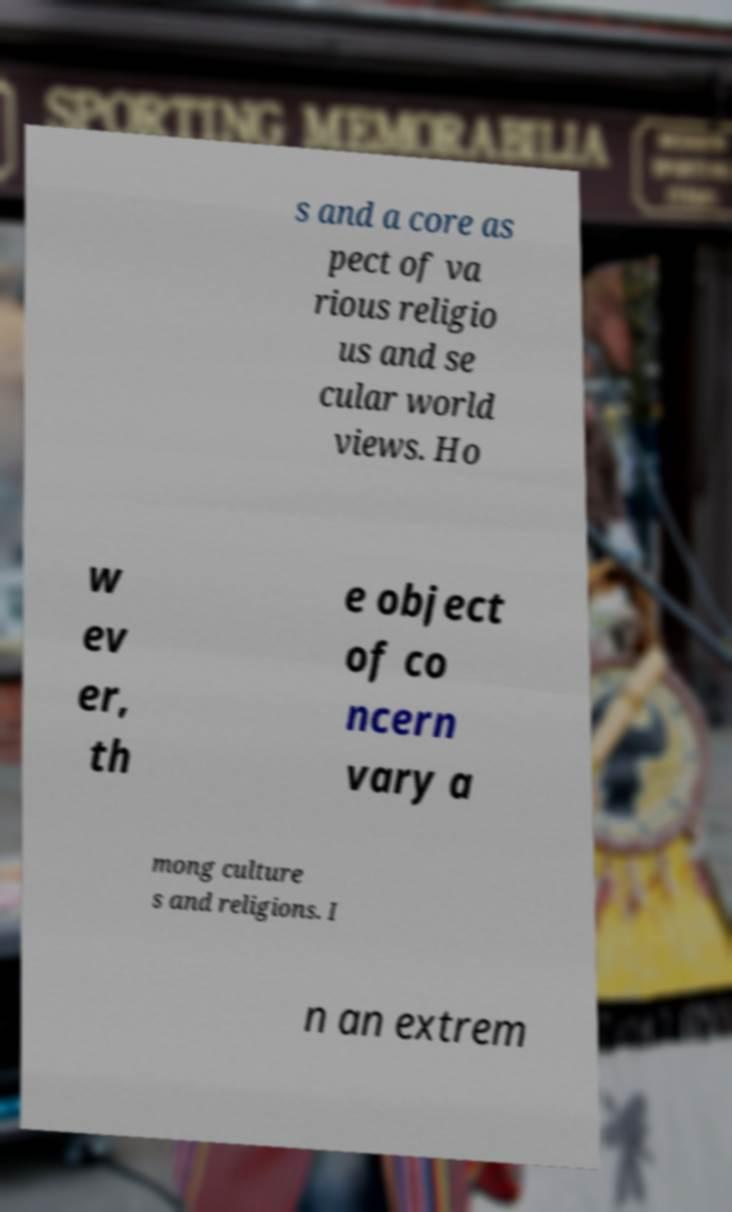I need the written content from this picture converted into text. Can you do that? s and a core as pect of va rious religio us and se cular world views. Ho w ev er, th e object of co ncern vary a mong culture s and religions. I n an extrem 